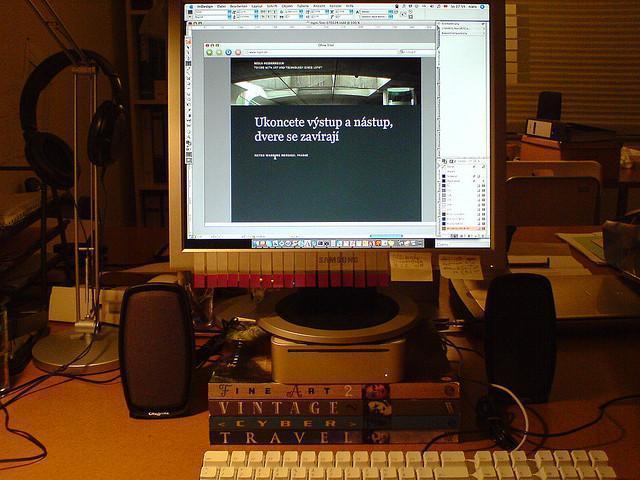What is the monitor sitting on top of above the desk?
Answer the question by selecting the correct answer among the 4 following choices.
Options: Papers, books, blocks, stand. Books. 